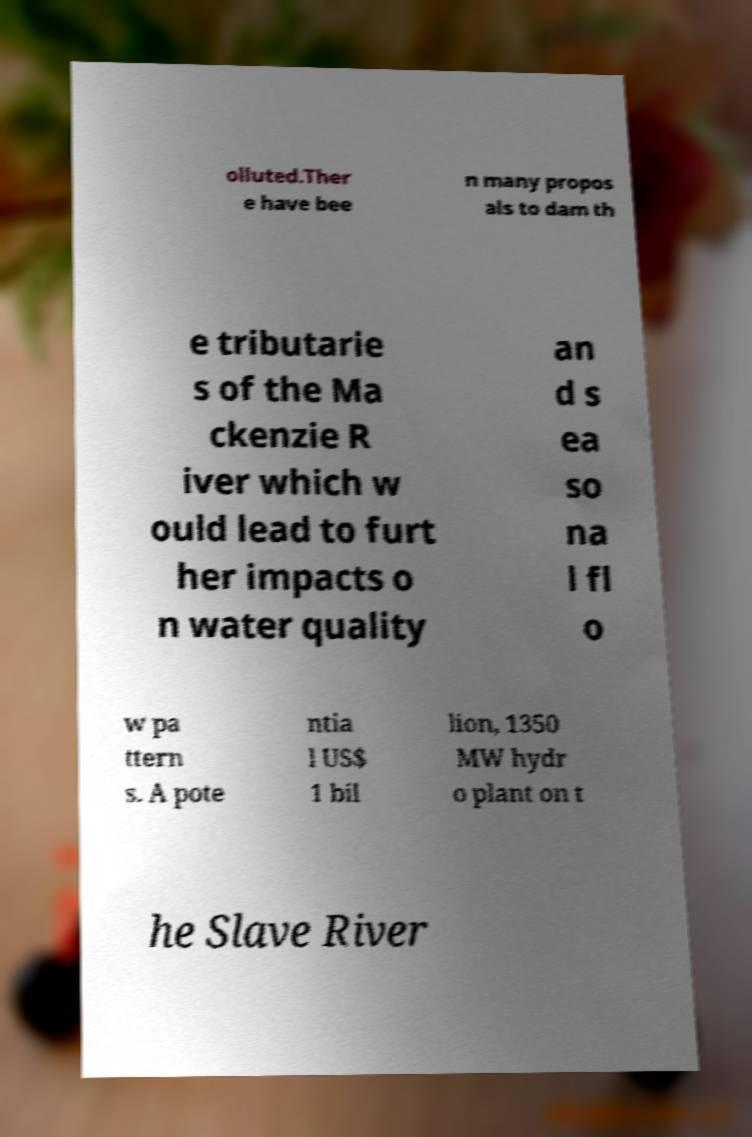For documentation purposes, I need the text within this image transcribed. Could you provide that? olluted.Ther e have bee n many propos als to dam th e tributarie s of the Ma ckenzie R iver which w ould lead to furt her impacts o n water quality an d s ea so na l fl o w pa ttern s. A pote ntia l US$ 1 bil lion, 1350 MW hydr o plant on t he Slave River 